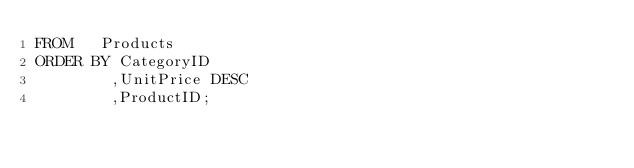<code> <loc_0><loc_0><loc_500><loc_500><_SQL_>FROM   Products
ORDER BY CategoryID
        ,UnitPrice DESC
        ,ProductID;
</code> 